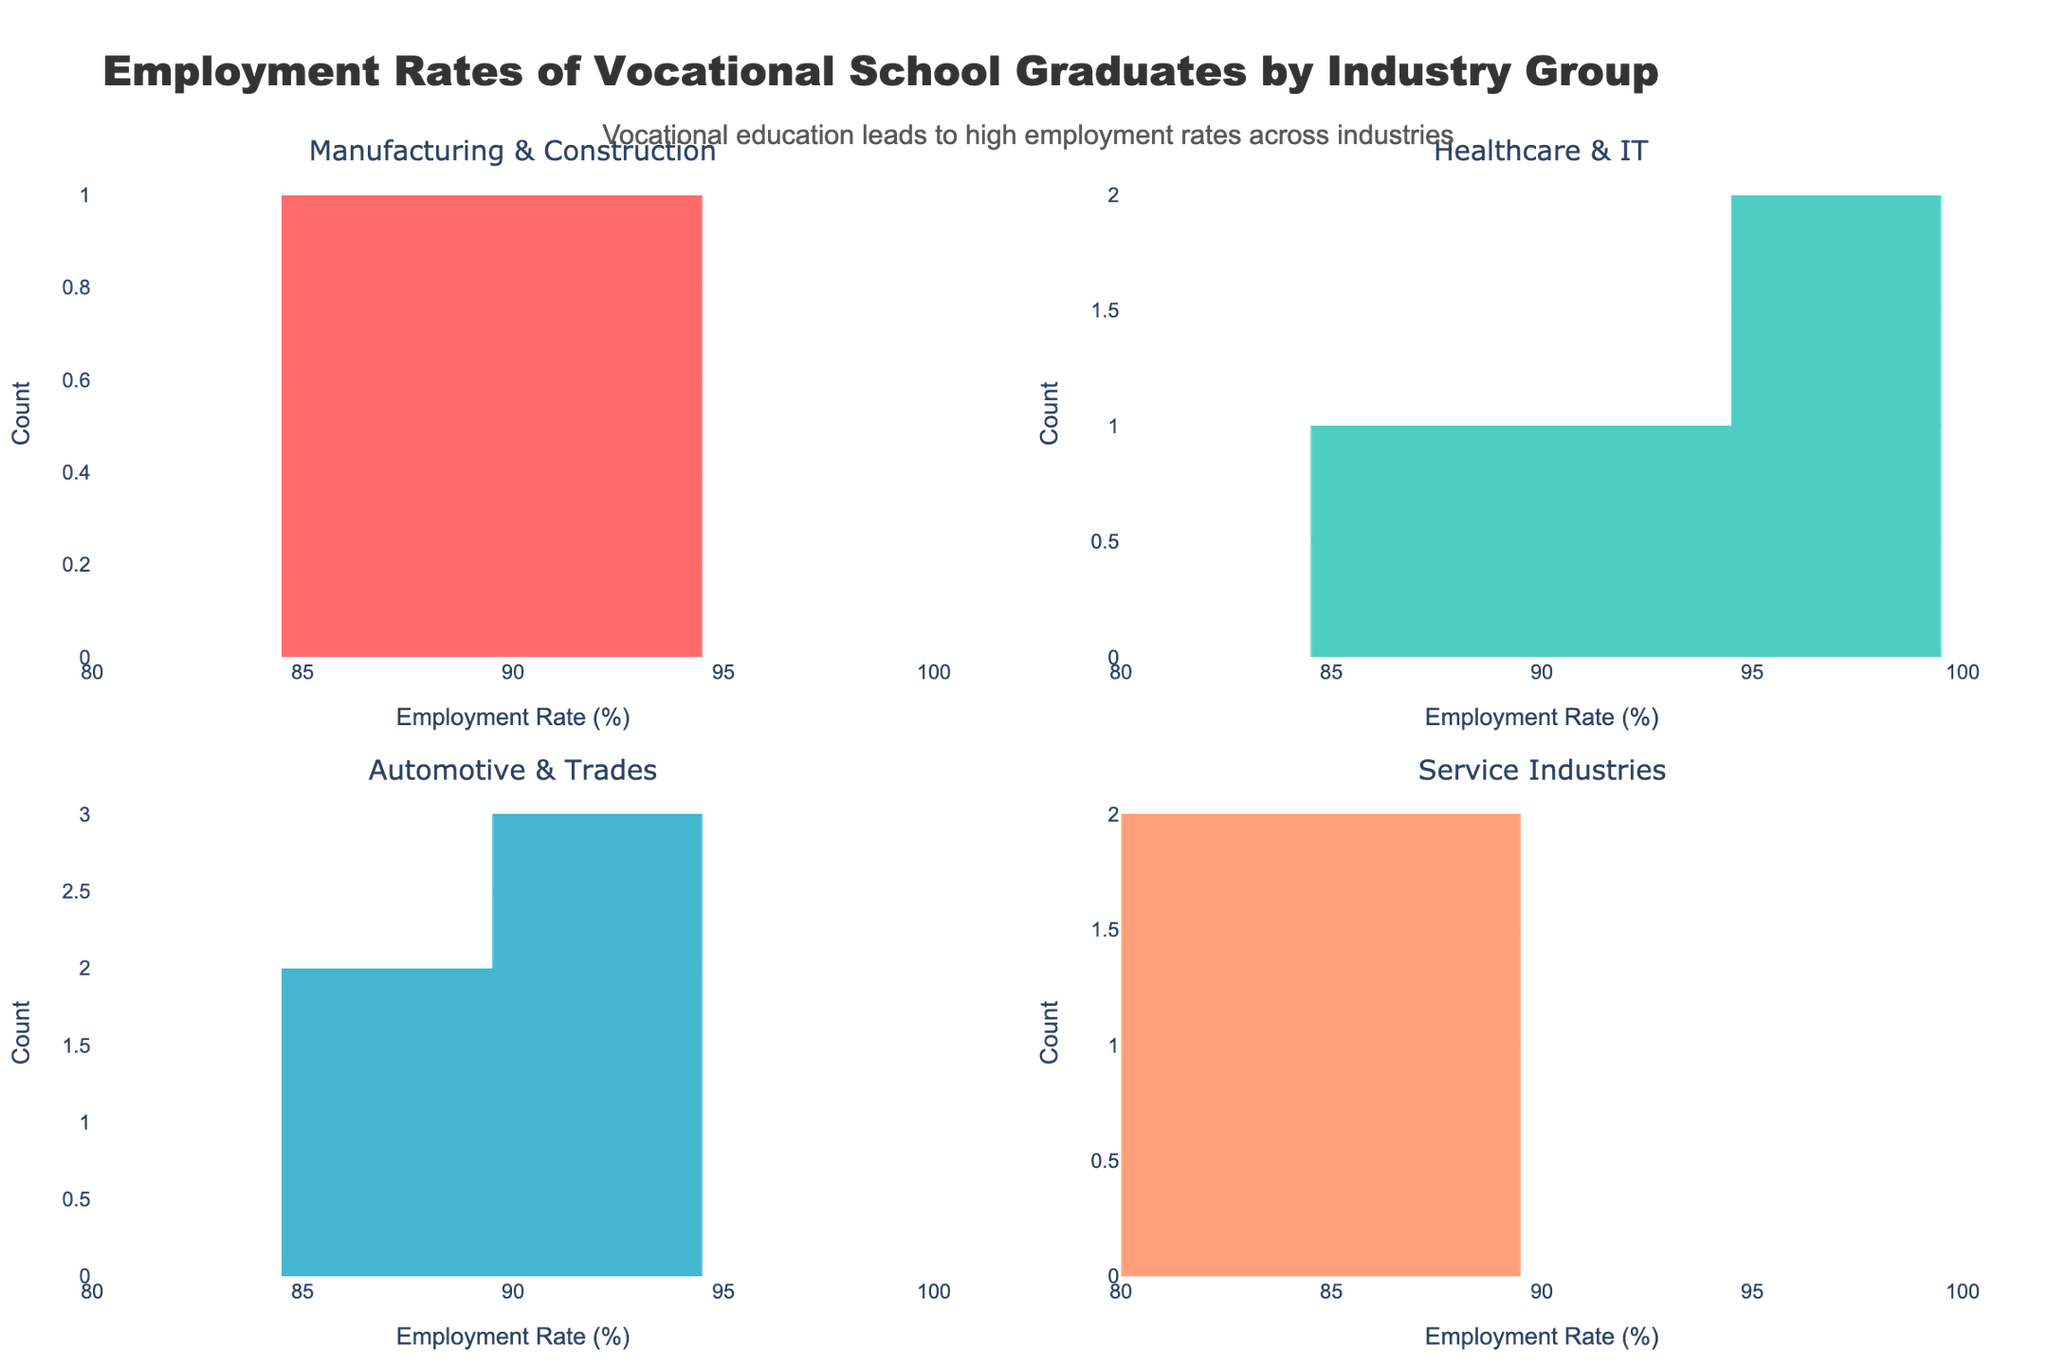What is the title of the figure? The title is located at the top of the figure, summarizing the overall subject of the plots.
Answer: Employment Rates of Vocational School Graduates by Industry Group How many industry groups are represented in the figure? There are four subplot titles, each representing a different industry group.
Answer: Four What is the employment rate range on the x-axis? The x-axis range is labeled and can be seen from the start to the end of the axis.
Answer: 80 to 100 Which industry group has the highest employment rate? The highest employment rate can be observed by looking at the rightmost bar in each subplot.
Answer: Healthcare & IT Between "Service Industries" and "Automotive & Trades," which one has a broader range of employment rates? By comparing the spread of the bars in both subplots, one can determine which subplot covers a wider range of employment rates.
Answer: Service Industries What can you infer from the distribution of employment rates in the "Healthcare & IT" subplot? By examining the concentration and distribution of the bars in this subplot, one can infer the range and commonality of employment rates within this group.
Answer: High employment rates, most are above 90% How many industries are represented in the "Service Industries" subplot? The number of unique bars in the subplot corresponds to the number of industries represented.
Answer: Four If the average employment rate is approximately measured for "Automotive & Trades," what would be your estimate? Estimate the average by considering the middle values of the bars in this subplot.
Answer: Around 89% Which industry within the "Manufacturing & Construction" subplot has a higher employment rate? By comparing the heights of individual bars within this subplot, one can determine which industry's employment rate is higher.
Answer: Manufacturing What does the annotation say about vocational education and employment rates across industries? The annotation is placed within the figure to provide a summary or key insight about the data presented.
Answer: Vocational education leads to high employment rates across industries 